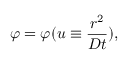Convert formula to latex. <formula><loc_0><loc_0><loc_500><loc_500>\varphi = \varphi ( u \equiv \frac { r ^ { 2 } } { D t } ) ,</formula> 